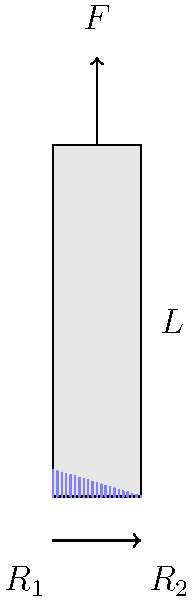As a music critic analyzing a pianist's performance, you notice the unique stress distribution on a piano key when pressed. Given a piano key of length $L$ with a force $F$ applied at its end, how would you describe the stress distribution along the key's length? What factors might influence this distribution and potentially affect the pianist's touch and control? To understand the stress distribution on a piano key, let's break it down step-by-step:

1. The piano key can be modeled as a cantilever beam fixed at one end and free at the other.

2. When a force $F$ is applied at the free end, it creates a bending moment that varies along the length of the key.

3. The bending moment $M$ at any point $x$ along the key is given by:
   $$M(x) = F(L-x)$$

4. The stress in the key is proportional to the bending moment. The maximum stress occurs at the fixed end (where $x=0$) and decreases linearly to zero at the free end (where $x=L$).

5. The stress distribution is triangular, with the maximum stress at the fixed end and zero stress at the free end.

6. Factors influencing this distribution include:
   a) Key material (affects stiffness and stress response)
   b) Key dimensions (length, width, and thickness)
   c) Applied force (varies with pianist's touch)
   d) Key pivot point design (affects the effective length)

7. This stress distribution affects the pianist's touch and control by:
   a) Influencing the key's resistance and response to pressure
   b) Affecting the key's return speed after being released
   c) Potentially causing slight deformation in the key over time

8. Understanding this stress distribution is crucial for piano designers and technicians to create keys that provide consistent feel and response across the keyboard, enhancing the pianist's performance.
Answer: Triangular stress distribution, maximum at fixed end, zero at free end. Influenced by key material, dimensions, applied force, and pivot design. Affects pianist's touch and control through key resistance, response, and long-term wear. 